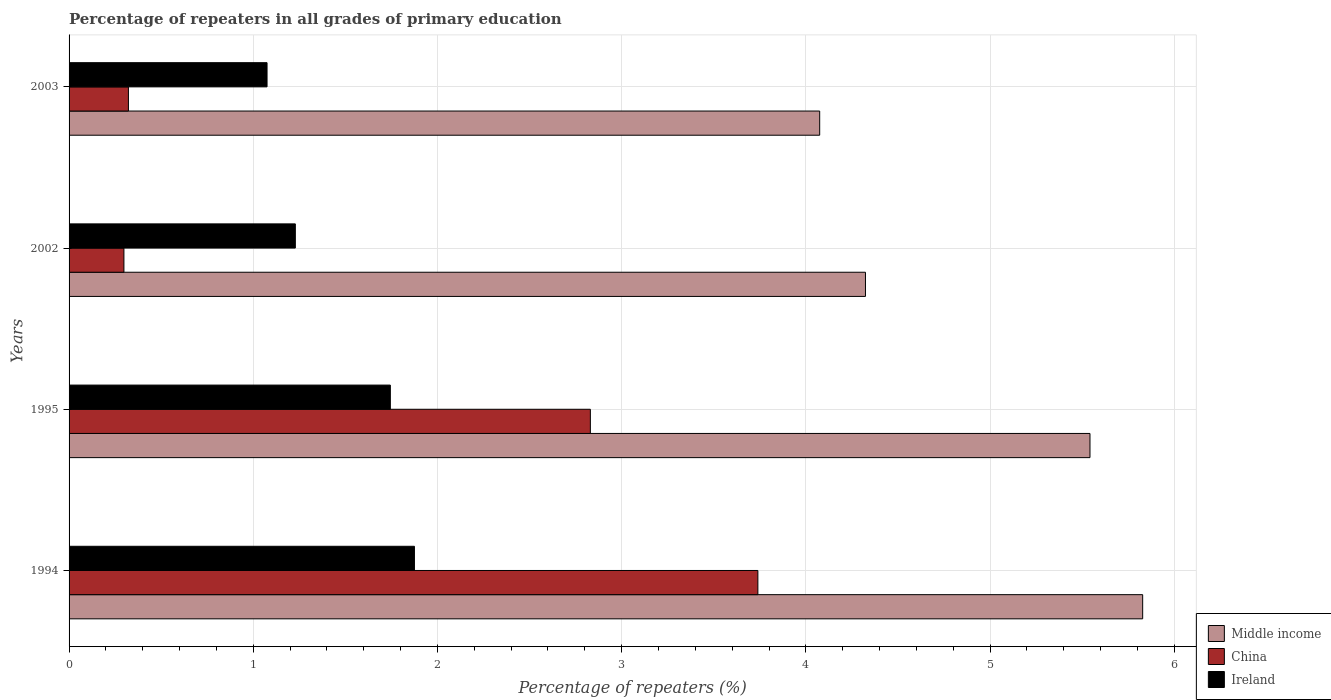How many different coloured bars are there?
Your answer should be very brief. 3. How many groups of bars are there?
Make the answer very short. 4. What is the label of the 1st group of bars from the top?
Ensure brevity in your answer.  2003. What is the percentage of repeaters in China in 1994?
Provide a succinct answer. 3.74. Across all years, what is the maximum percentage of repeaters in Ireland?
Give a very brief answer. 1.88. Across all years, what is the minimum percentage of repeaters in Middle income?
Your answer should be very brief. 4.08. In which year was the percentage of repeaters in Ireland maximum?
Ensure brevity in your answer.  1994. In which year was the percentage of repeaters in Middle income minimum?
Make the answer very short. 2003. What is the total percentage of repeaters in China in the graph?
Keep it short and to the point. 7.19. What is the difference between the percentage of repeaters in Ireland in 1994 and that in 1995?
Offer a terse response. 0.13. What is the difference between the percentage of repeaters in China in 2003 and the percentage of repeaters in Middle income in 2002?
Make the answer very short. -4. What is the average percentage of repeaters in Ireland per year?
Your response must be concise. 1.48. In the year 2002, what is the difference between the percentage of repeaters in Middle income and percentage of repeaters in Ireland?
Your answer should be very brief. 3.1. In how many years, is the percentage of repeaters in China greater than 1.4 %?
Provide a succinct answer. 2. What is the ratio of the percentage of repeaters in Middle income in 1995 to that in 2003?
Offer a very short reply. 1.36. Is the difference between the percentage of repeaters in Middle income in 2002 and 2003 greater than the difference between the percentage of repeaters in Ireland in 2002 and 2003?
Offer a very short reply. Yes. What is the difference between the highest and the second highest percentage of repeaters in Ireland?
Offer a terse response. 0.13. What is the difference between the highest and the lowest percentage of repeaters in China?
Your answer should be very brief. 3.44. Is the sum of the percentage of repeaters in Ireland in 1994 and 1995 greater than the maximum percentage of repeaters in China across all years?
Offer a terse response. No. What does the 1st bar from the top in 1995 represents?
Provide a succinct answer. Ireland. What does the 3rd bar from the bottom in 2003 represents?
Ensure brevity in your answer.  Ireland. Is it the case that in every year, the sum of the percentage of repeaters in Ireland and percentage of repeaters in China is greater than the percentage of repeaters in Middle income?
Keep it short and to the point. No. How many bars are there?
Keep it short and to the point. 12. Are all the bars in the graph horizontal?
Ensure brevity in your answer.  Yes. What is the difference between two consecutive major ticks on the X-axis?
Your answer should be very brief. 1. Are the values on the major ticks of X-axis written in scientific E-notation?
Ensure brevity in your answer.  No. Does the graph contain any zero values?
Your response must be concise. No. Does the graph contain grids?
Ensure brevity in your answer.  Yes. How many legend labels are there?
Your answer should be compact. 3. How are the legend labels stacked?
Provide a succinct answer. Vertical. What is the title of the graph?
Keep it short and to the point. Percentage of repeaters in all grades of primary education. What is the label or title of the X-axis?
Give a very brief answer. Percentage of repeaters (%). What is the Percentage of repeaters (%) of Middle income in 1994?
Your response must be concise. 5.83. What is the Percentage of repeaters (%) in China in 1994?
Ensure brevity in your answer.  3.74. What is the Percentage of repeaters (%) of Ireland in 1994?
Provide a succinct answer. 1.88. What is the Percentage of repeaters (%) of Middle income in 1995?
Offer a very short reply. 5.54. What is the Percentage of repeaters (%) of China in 1995?
Your response must be concise. 2.83. What is the Percentage of repeaters (%) of Ireland in 1995?
Make the answer very short. 1.74. What is the Percentage of repeaters (%) of Middle income in 2002?
Give a very brief answer. 4.32. What is the Percentage of repeaters (%) in China in 2002?
Offer a very short reply. 0.3. What is the Percentage of repeaters (%) of Ireland in 2002?
Provide a succinct answer. 1.23. What is the Percentage of repeaters (%) in Middle income in 2003?
Give a very brief answer. 4.08. What is the Percentage of repeaters (%) in China in 2003?
Make the answer very short. 0.32. What is the Percentage of repeaters (%) in Ireland in 2003?
Provide a succinct answer. 1.07. Across all years, what is the maximum Percentage of repeaters (%) in Middle income?
Your answer should be very brief. 5.83. Across all years, what is the maximum Percentage of repeaters (%) of China?
Your answer should be very brief. 3.74. Across all years, what is the maximum Percentage of repeaters (%) of Ireland?
Make the answer very short. 1.88. Across all years, what is the minimum Percentage of repeaters (%) of Middle income?
Your answer should be very brief. 4.08. Across all years, what is the minimum Percentage of repeaters (%) of China?
Ensure brevity in your answer.  0.3. Across all years, what is the minimum Percentage of repeaters (%) of Ireland?
Make the answer very short. 1.07. What is the total Percentage of repeaters (%) in Middle income in the graph?
Your response must be concise. 19.77. What is the total Percentage of repeaters (%) in China in the graph?
Offer a very short reply. 7.19. What is the total Percentage of repeaters (%) in Ireland in the graph?
Give a very brief answer. 5.92. What is the difference between the Percentage of repeaters (%) in Middle income in 1994 and that in 1995?
Provide a succinct answer. 0.29. What is the difference between the Percentage of repeaters (%) of China in 1994 and that in 1995?
Your answer should be very brief. 0.91. What is the difference between the Percentage of repeaters (%) of Ireland in 1994 and that in 1995?
Ensure brevity in your answer.  0.13. What is the difference between the Percentage of repeaters (%) in Middle income in 1994 and that in 2002?
Provide a short and direct response. 1.5. What is the difference between the Percentage of repeaters (%) of China in 1994 and that in 2002?
Keep it short and to the point. 3.44. What is the difference between the Percentage of repeaters (%) of Ireland in 1994 and that in 2002?
Ensure brevity in your answer.  0.65. What is the difference between the Percentage of repeaters (%) of Middle income in 1994 and that in 2003?
Give a very brief answer. 1.75. What is the difference between the Percentage of repeaters (%) in China in 1994 and that in 2003?
Your answer should be compact. 3.42. What is the difference between the Percentage of repeaters (%) in Ireland in 1994 and that in 2003?
Offer a very short reply. 0.8. What is the difference between the Percentage of repeaters (%) of Middle income in 1995 and that in 2002?
Offer a terse response. 1.22. What is the difference between the Percentage of repeaters (%) in China in 1995 and that in 2002?
Keep it short and to the point. 2.53. What is the difference between the Percentage of repeaters (%) of Ireland in 1995 and that in 2002?
Your response must be concise. 0.52. What is the difference between the Percentage of repeaters (%) of Middle income in 1995 and that in 2003?
Keep it short and to the point. 1.47. What is the difference between the Percentage of repeaters (%) in China in 1995 and that in 2003?
Keep it short and to the point. 2.51. What is the difference between the Percentage of repeaters (%) of Ireland in 1995 and that in 2003?
Give a very brief answer. 0.67. What is the difference between the Percentage of repeaters (%) of Middle income in 2002 and that in 2003?
Give a very brief answer. 0.25. What is the difference between the Percentage of repeaters (%) in China in 2002 and that in 2003?
Make the answer very short. -0.02. What is the difference between the Percentage of repeaters (%) in Ireland in 2002 and that in 2003?
Give a very brief answer. 0.15. What is the difference between the Percentage of repeaters (%) in Middle income in 1994 and the Percentage of repeaters (%) in China in 1995?
Provide a short and direct response. 3. What is the difference between the Percentage of repeaters (%) of Middle income in 1994 and the Percentage of repeaters (%) of Ireland in 1995?
Provide a short and direct response. 4.08. What is the difference between the Percentage of repeaters (%) of China in 1994 and the Percentage of repeaters (%) of Ireland in 1995?
Offer a very short reply. 2. What is the difference between the Percentage of repeaters (%) of Middle income in 1994 and the Percentage of repeaters (%) of China in 2002?
Your answer should be very brief. 5.53. What is the difference between the Percentage of repeaters (%) of Middle income in 1994 and the Percentage of repeaters (%) of Ireland in 2002?
Offer a terse response. 4.6. What is the difference between the Percentage of repeaters (%) of China in 1994 and the Percentage of repeaters (%) of Ireland in 2002?
Provide a short and direct response. 2.51. What is the difference between the Percentage of repeaters (%) of Middle income in 1994 and the Percentage of repeaters (%) of China in 2003?
Ensure brevity in your answer.  5.51. What is the difference between the Percentage of repeaters (%) in Middle income in 1994 and the Percentage of repeaters (%) in Ireland in 2003?
Your response must be concise. 4.75. What is the difference between the Percentage of repeaters (%) of China in 1994 and the Percentage of repeaters (%) of Ireland in 2003?
Provide a succinct answer. 2.66. What is the difference between the Percentage of repeaters (%) in Middle income in 1995 and the Percentage of repeaters (%) in China in 2002?
Offer a very short reply. 5.24. What is the difference between the Percentage of repeaters (%) of Middle income in 1995 and the Percentage of repeaters (%) of Ireland in 2002?
Ensure brevity in your answer.  4.31. What is the difference between the Percentage of repeaters (%) of China in 1995 and the Percentage of repeaters (%) of Ireland in 2002?
Provide a succinct answer. 1.6. What is the difference between the Percentage of repeaters (%) of Middle income in 1995 and the Percentage of repeaters (%) of China in 2003?
Provide a short and direct response. 5.22. What is the difference between the Percentage of repeaters (%) of Middle income in 1995 and the Percentage of repeaters (%) of Ireland in 2003?
Your answer should be very brief. 4.47. What is the difference between the Percentage of repeaters (%) of China in 1995 and the Percentage of repeaters (%) of Ireland in 2003?
Your response must be concise. 1.76. What is the difference between the Percentage of repeaters (%) in Middle income in 2002 and the Percentage of repeaters (%) in China in 2003?
Keep it short and to the point. 4. What is the difference between the Percentage of repeaters (%) of Middle income in 2002 and the Percentage of repeaters (%) of Ireland in 2003?
Provide a short and direct response. 3.25. What is the difference between the Percentage of repeaters (%) of China in 2002 and the Percentage of repeaters (%) of Ireland in 2003?
Provide a short and direct response. -0.78. What is the average Percentage of repeaters (%) in Middle income per year?
Your answer should be very brief. 4.94. What is the average Percentage of repeaters (%) of China per year?
Make the answer very short. 1.8. What is the average Percentage of repeaters (%) of Ireland per year?
Provide a short and direct response. 1.48. In the year 1994, what is the difference between the Percentage of repeaters (%) in Middle income and Percentage of repeaters (%) in China?
Give a very brief answer. 2.09. In the year 1994, what is the difference between the Percentage of repeaters (%) of Middle income and Percentage of repeaters (%) of Ireland?
Provide a short and direct response. 3.95. In the year 1994, what is the difference between the Percentage of repeaters (%) of China and Percentage of repeaters (%) of Ireland?
Make the answer very short. 1.86. In the year 1995, what is the difference between the Percentage of repeaters (%) in Middle income and Percentage of repeaters (%) in China?
Provide a short and direct response. 2.71. In the year 1995, what is the difference between the Percentage of repeaters (%) in Middle income and Percentage of repeaters (%) in Ireland?
Your answer should be very brief. 3.8. In the year 1995, what is the difference between the Percentage of repeaters (%) of China and Percentage of repeaters (%) of Ireland?
Keep it short and to the point. 1.09. In the year 2002, what is the difference between the Percentage of repeaters (%) in Middle income and Percentage of repeaters (%) in China?
Provide a succinct answer. 4.03. In the year 2002, what is the difference between the Percentage of repeaters (%) in Middle income and Percentage of repeaters (%) in Ireland?
Keep it short and to the point. 3.1. In the year 2002, what is the difference between the Percentage of repeaters (%) in China and Percentage of repeaters (%) in Ireland?
Ensure brevity in your answer.  -0.93. In the year 2003, what is the difference between the Percentage of repeaters (%) of Middle income and Percentage of repeaters (%) of China?
Offer a terse response. 3.75. In the year 2003, what is the difference between the Percentage of repeaters (%) in Middle income and Percentage of repeaters (%) in Ireland?
Your answer should be very brief. 3. In the year 2003, what is the difference between the Percentage of repeaters (%) in China and Percentage of repeaters (%) in Ireland?
Provide a short and direct response. -0.75. What is the ratio of the Percentage of repeaters (%) in Middle income in 1994 to that in 1995?
Offer a terse response. 1.05. What is the ratio of the Percentage of repeaters (%) in China in 1994 to that in 1995?
Your answer should be compact. 1.32. What is the ratio of the Percentage of repeaters (%) of Ireland in 1994 to that in 1995?
Give a very brief answer. 1.07. What is the ratio of the Percentage of repeaters (%) in Middle income in 1994 to that in 2002?
Ensure brevity in your answer.  1.35. What is the ratio of the Percentage of repeaters (%) of China in 1994 to that in 2002?
Provide a succinct answer. 12.56. What is the ratio of the Percentage of repeaters (%) of Ireland in 1994 to that in 2002?
Your answer should be compact. 1.53. What is the ratio of the Percentage of repeaters (%) of Middle income in 1994 to that in 2003?
Your response must be concise. 1.43. What is the ratio of the Percentage of repeaters (%) of China in 1994 to that in 2003?
Provide a succinct answer. 11.6. What is the ratio of the Percentage of repeaters (%) in Ireland in 1994 to that in 2003?
Your answer should be compact. 1.74. What is the ratio of the Percentage of repeaters (%) in Middle income in 1995 to that in 2002?
Provide a succinct answer. 1.28. What is the ratio of the Percentage of repeaters (%) of China in 1995 to that in 2002?
Provide a short and direct response. 9.5. What is the ratio of the Percentage of repeaters (%) of Ireland in 1995 to that in 2002?
Provide a short and direct response. 1.42. What is the ratio of the Percentage of repeaters (%) in Middle income in 1995 to that in 2003?
Provide a short and direct response. 1.36. What is the ratio of the Percentage of repeaters (%) in China in 1995 to that in 2003?
Your answer should be very brief. 8.78. What is the ratio of the Percentage of repeaters (%) of Ireland in 1995 to that in 2003?
Provide a short and direct response. 1.62. What is the ratio of the Percentage of repeaters (%) of Middle income in 2002 to that in 2003?
Offer a terse response. 1.06. What is the ratio of the Percentage of repeaters (%) of China in 2002 to that in 2003?
Give a very brief answer. 0.92. What is the difference between the highest and the second highest Percentage of repeaters (%) of Middle income?
Your response must be concise. 0.29. What is the difference between the highest and the second highest Percentage of repeaters (%) in China?
Give a very brief answer. 0.91. What is the difference between the highest and the second highest Percentage of repeaters (%) in Ireland?
Your answer should be compact. 0.13. What is the difference between the highest and the lowest Percentage of repeaters (%) in Middle income?
Ensure brevity in your answer.  1.75. What is the difference between the highest and the lowest Percentage of repeaters (%) of China?
Keep it short and to the point. 3.44. What is the difference between the highest and the lowest Percentage of repeaters (%) in Ireland?
Your response must be concise. 0.8. 